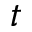<formula> <loc_0><loc_0><loc_500><loc_500>t</formula> 